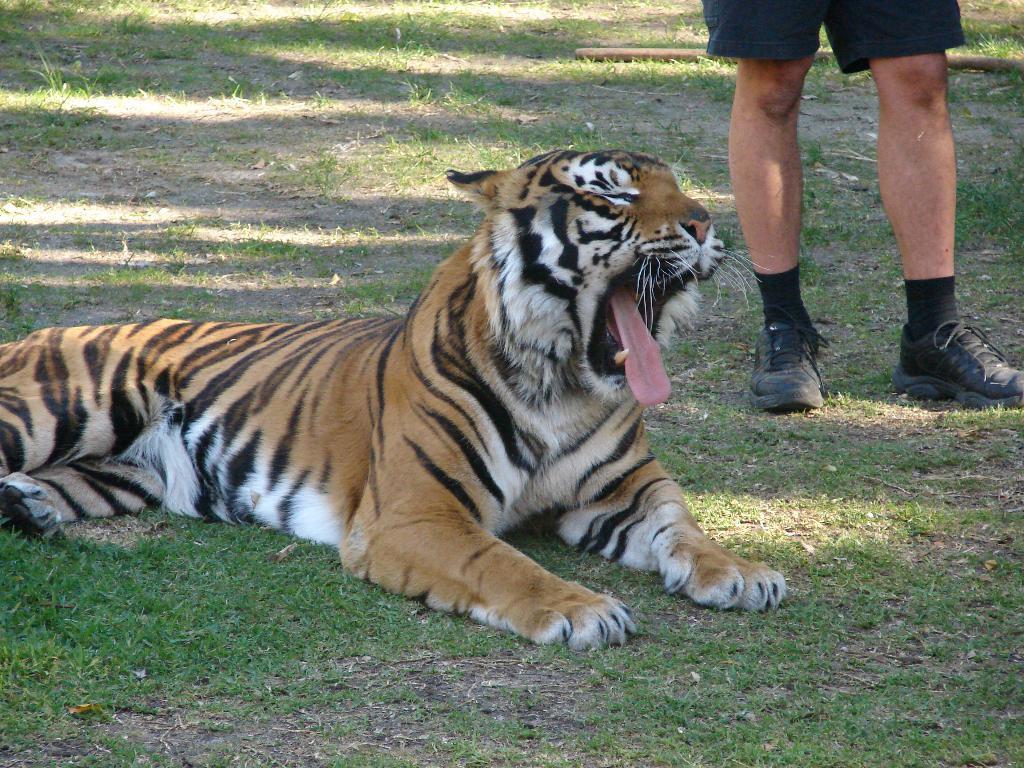Can you describe this image briefly? In this picture there is a tiger sitting on the grass and there is a person standing. At the bottom there is grass and there is mud and at the back there is a stick on the grass. 